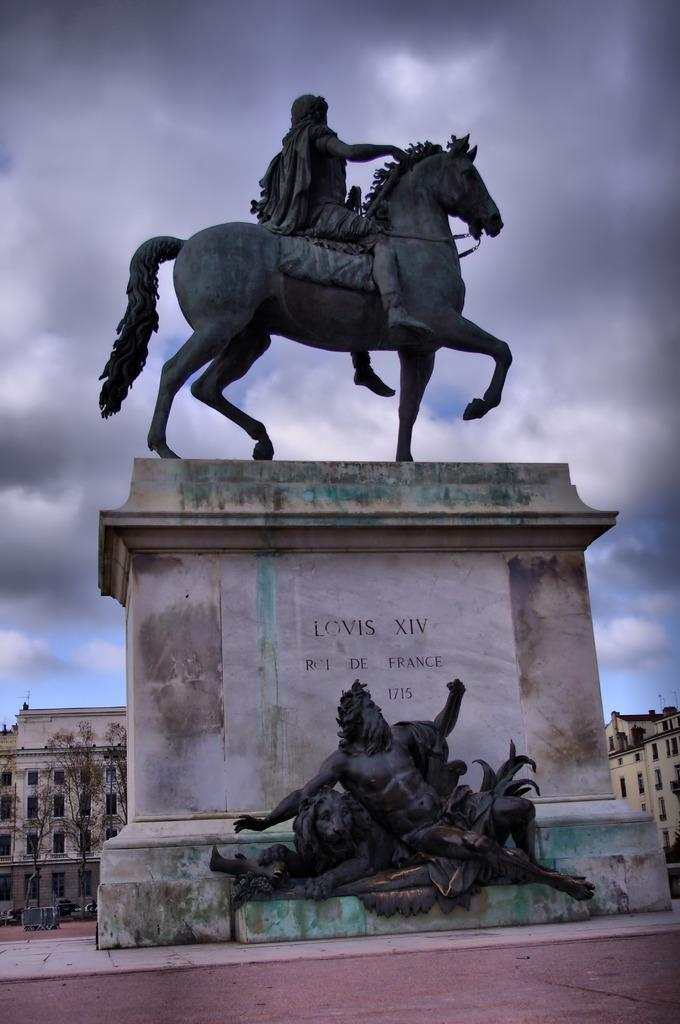What is the main subject of the image? There is a sculpture in the center of the image. Can you describe the sculpture in more detail? Unfortunately, the provided facts do not offer any additional details about the sculpture. Is there anything else in the image besides the sculpture? The facts do not mention any other objects or subjects in the image. What type of arm is attached to the cannon in the image? There is no cannon or arm present in the image; it only features a sculpture. How many corks are visible in the image? There are no corks present in the image. 